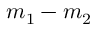<formula> <loc_0><loc_0><loc_500><loc_500>m _ { 1 } - m _ { 2 }</formula> 